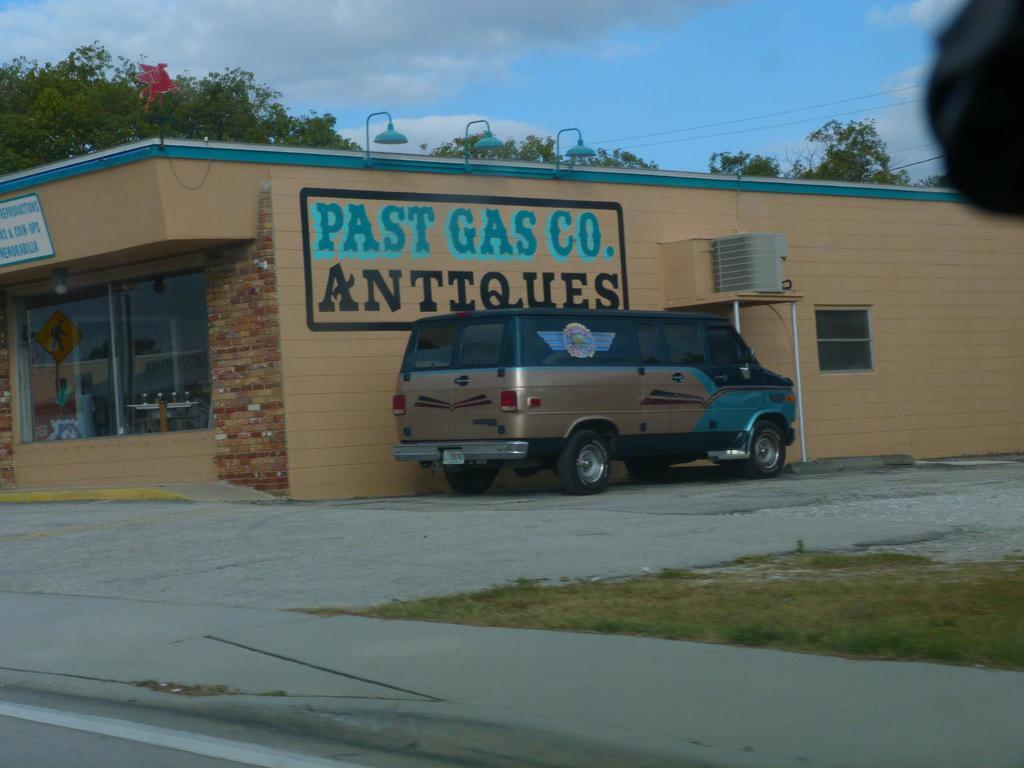<image>
Offer a succinct explanation of the picture presented. A store with the word Past Gas Co Antiques on the side. 